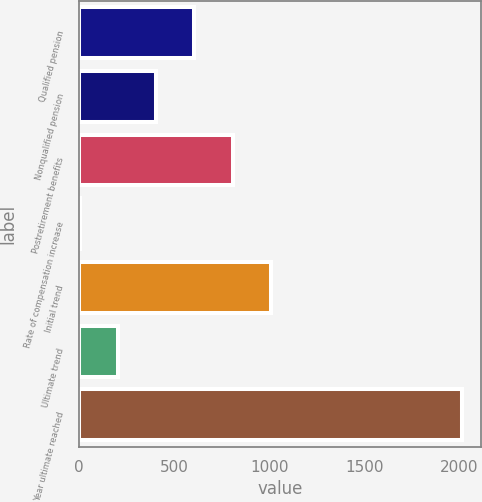Convert chart. <chart><loc_0><loc_0><loc_500><loc_500><bar_chart><fcel>Qualified pension<fcel>Nonqualified pension<fcel>Postretirement benefits<fcel>Rate of compensation increase<fcel>Initial trend<fcel>Ultimate trend<fcel>Year ultimate reached<nl><fcel>607<fcel>406<fcel>808<fcel>4<fcel>1009<fcel>205<fcel>2014<nl></chart> 